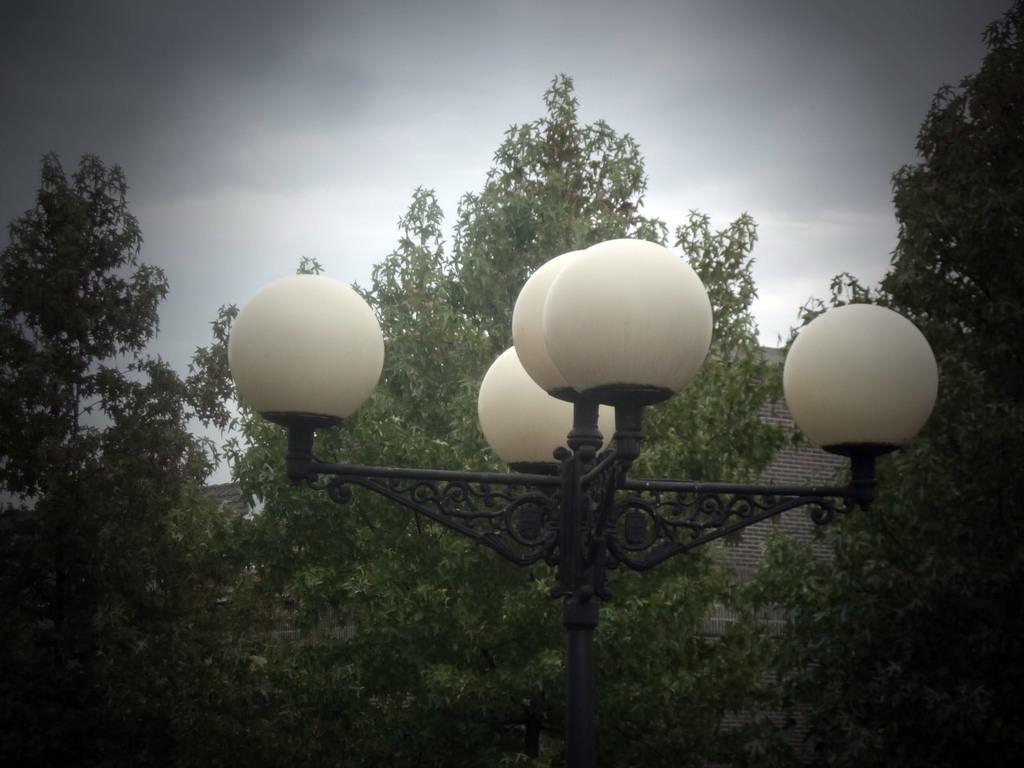How would you summarize this image in a sentence or two? In front of the picture, we see a pole which has the lights. There are trees and a building in the background. At the top, we see the sky. 